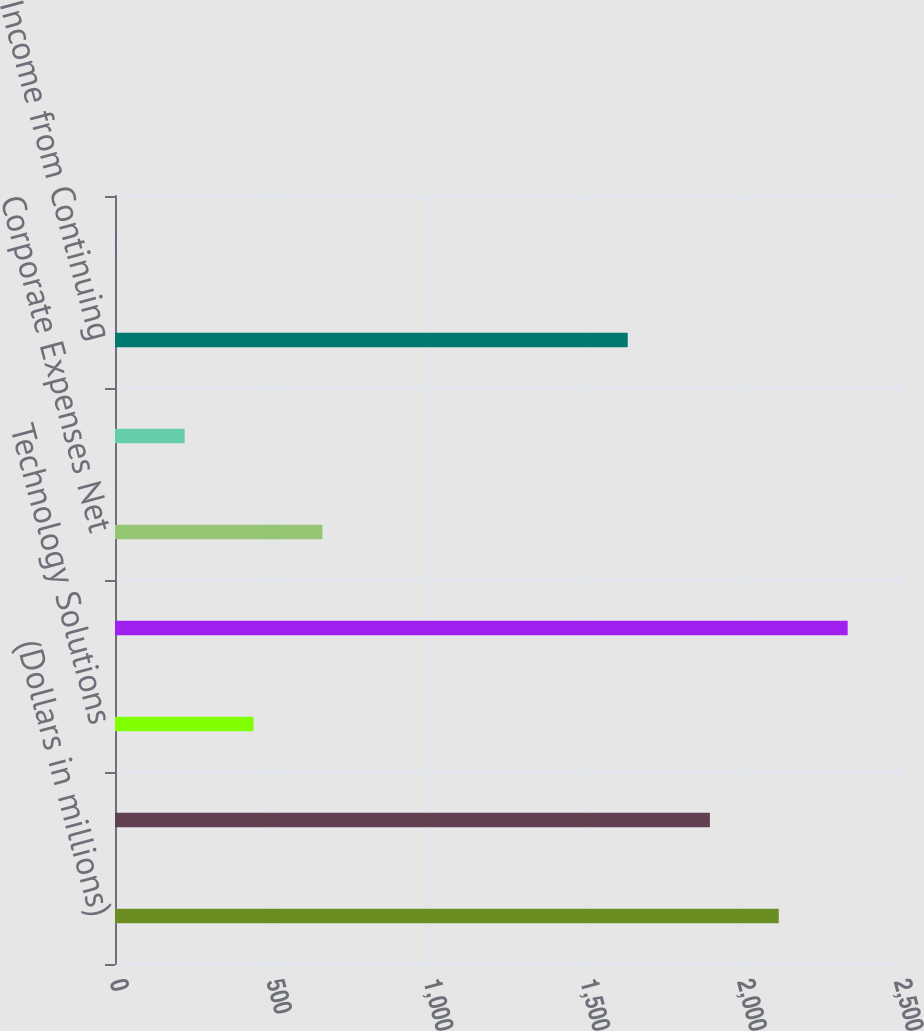Convert chart. <chart><loc_0><loc_0><loc_500><loc_500><bar_chart><fcel>(Dollars in millions)<fcel>Distribution Solutions ^ (2)<fcel>Technology Solutions<fcel>Subtotal<fcel>Corporate Expenses Net<fcel>Interest Expense<fcel>Income from Continuing<fcel>Distribution Solutions<nl><fcel>2116.63<fcel>1897<fcel>441.63<fcel>2336.26<fcel>661.26<fcel>222<fcel>1635<fcel>1.74<nl></chart> 